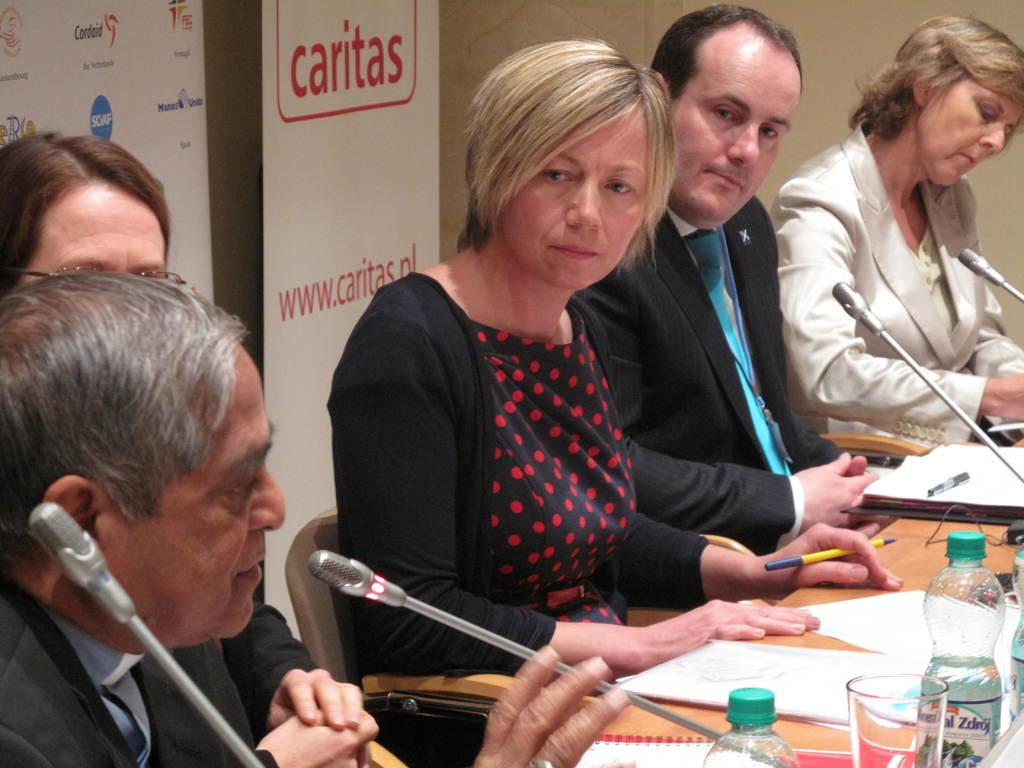What are the people in the image doing? The people in the image are sitting. What objects are in front of the people? There are microphones, papers, bottles, and glasses in front of the people. What can be seen at the back of the people? There is a banner at the back of the people. How do the giants interact with the people in the image? There are no giants present in the image; it only features people. 